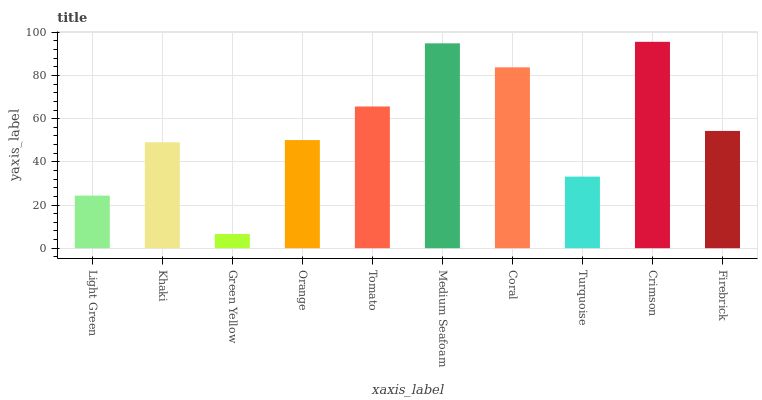Is Green Yellow the minimum?
Answer yes or no. Yes. Is Crimson the maximum?
Answer yes or no. Yes. Is Khaki the minimum?
Answer yes or no. No. Is Khaki the maximum?
Answer yes or no. No. Is Khaki greater than Light Green?
Answer yes or no. Yes. Is Light Green less than Khaki?
Answer yes or no. Yes. Is Light Green greater than Khaki?
Answer yes or no. No. Is Khaki less than Light Green?
Answer yes or no. No. Is Firebrick the high median?
Answer yes or no. Yes. Is Orange the low median?
Answer yes or no. Yes. Is Orange the high median?
Answer yes or no. No. Is Medium Seafoam the low median?
Answer yes or no. No. 